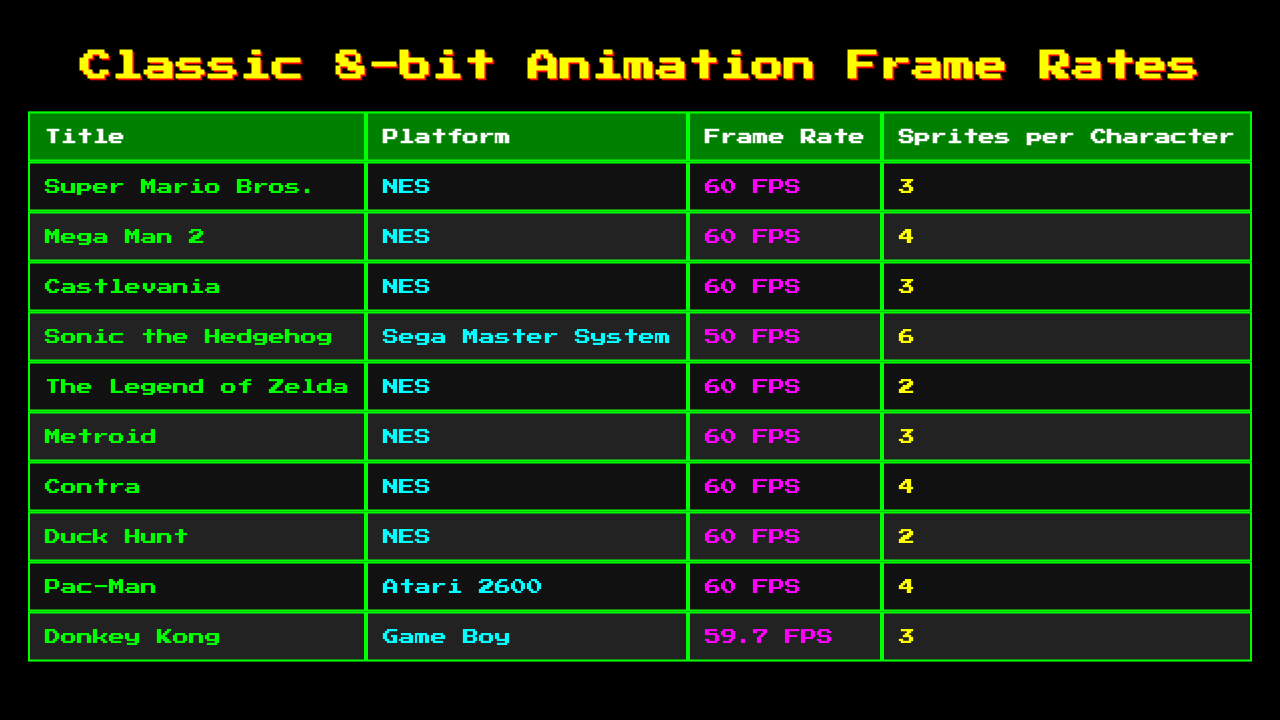What is the frame rate of "Escape from the Castle"? "Escape from the Castle" is not included in the list of classic 8-bit animations, therefore it does not have a recorded frame rate in the table.
Answer: Not applicable What is the maximum frame rate for the animations listed? The highest frame rate among the listed animations is 60 FPS, which is shared by several titles.
Answer: 60 FPS Which platform has the highest number of sprites per character in the table? "Sonic the Hedgehog," which runs on the Sega Master System, has the highest sprites per character at 6, more than any of the other listed games.
Answer: Sega Master System Is "Donkey Kong" the only Game Boy title in the list? Yes, according to the table, "Donkey Kong" is the only title listed for the Game Boy platform.
Answer: Yes On the NES platform, what is the average number of sprites per character for the games? The sprites per character for NES titles are 3, 4, 3, 2, 3, 4, and 2, which totals 21 across 7 titles. Dividing by 7 gives an average of 3.
Answer: 3 Do any animations have a frame rate lower than 60 FPS? Yes, "Sonic the Hedgehog" has a frame rate of 50 FPS, which is lower than 60 FPS observed in many other animations.
Answer: Yes How many distinct platforms are represented in the table? The platforms include NES, Sega Master System, Atari 2600, and Game Boy. That totals up to 4 distinct platforms across the listed animations.
Answer: 4 Which game has the least number of sprites per character? "The Legend of Zelda" has the least at 2 sprites per character among the games listed for the NES platform.
Answer: The Legend of Zelda Which game has the highest frame rate and also the lowest sprites per character? "Duck Hunt" has a frame rate of 60 FPS and the lowest number of sprites per character at 2 among the games with the highest frame rate.
Answer: Duck Hunt What is the total frame rate of all the games listed in the table? By adding the frame rates (60 + 60 + 60 + 50 + 60 + 60 + 60 + 60 + 59.7 = 459.7), we find the total frame rate is 459.7.
Answer: 459.7 